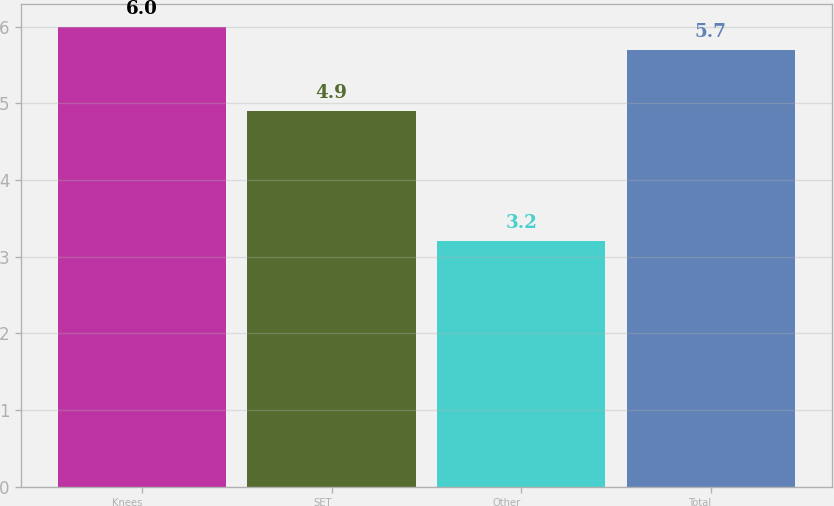Convert chart to OTSL. <chart><loc_0><loc_0><loc_500><loc_500><bar_chart><fcel>Knees<fcel>SET<fcel>Other<fcel>Total<nl><fcel>6<fcel>4.9<fcel>3.2<fcel>5.7<nl></chart> 